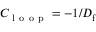Convert formula to latex. <formula><loc_0><loc_0><loc_500><loc_500>C _ { l o o p } = - 1 / D _ { f }</formula> 